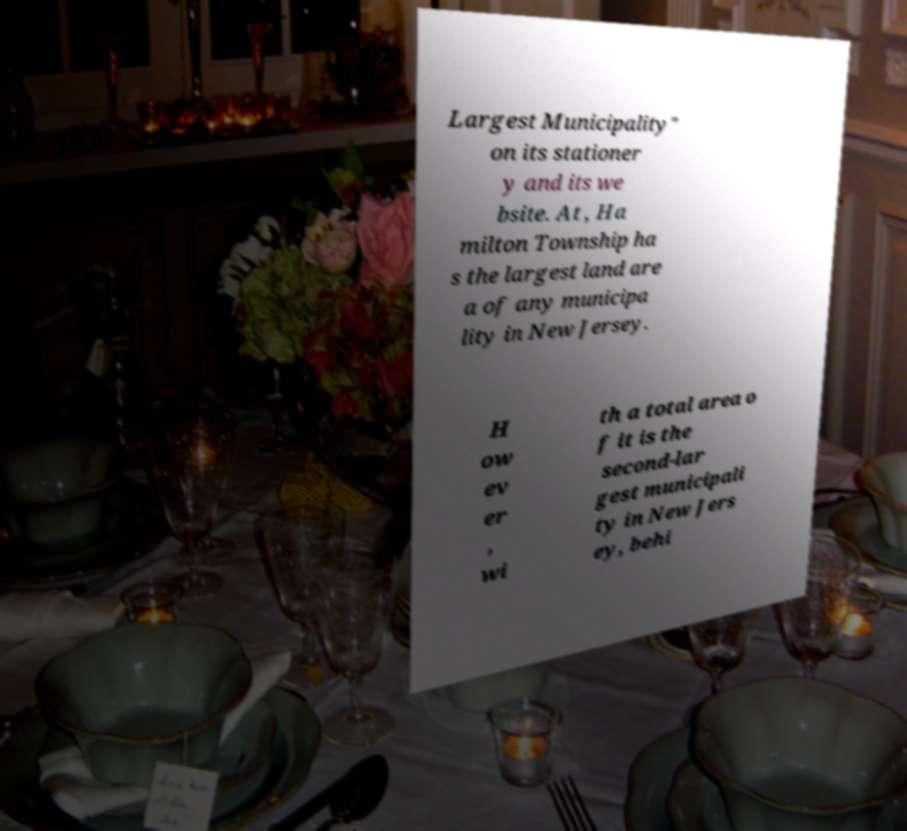Can you accurately transcribe the text from the provided image for me? Largest Municipality" on its stationer y and its we bsite. At , Ha milton Township ha s the largest land are a of any municipa lity in New Jersey. H ow ev er , wi th a total area o f it is the second-lar gest municipali ty in New Jers ey, behi 